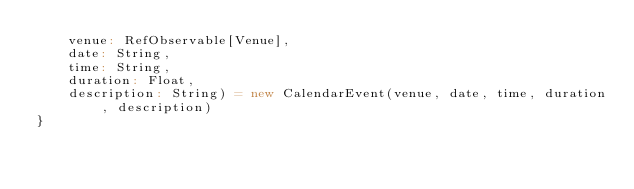Convert code to text. <code><loc_0><loc_0><loc_500><loc_500><_Scala_>    venue: RefObservable[Venue],
    date: String,
    time: String,
    duration: Float,
    description: String) = new CalendarEvent(venue, date, time, duration, description)
}
    

</code> 